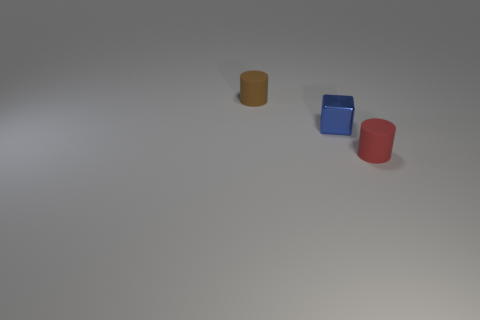Can this image tell us anything about the texture of the objects? Certainly, the way light reflects off the surfaces suggests that the objects have a matte finish. There's a lack of sharp, bright highlights one would expect from a highly glossy texture. This matte quality is further emphasized by the subtle variations in color intensity across the contours of each object. 